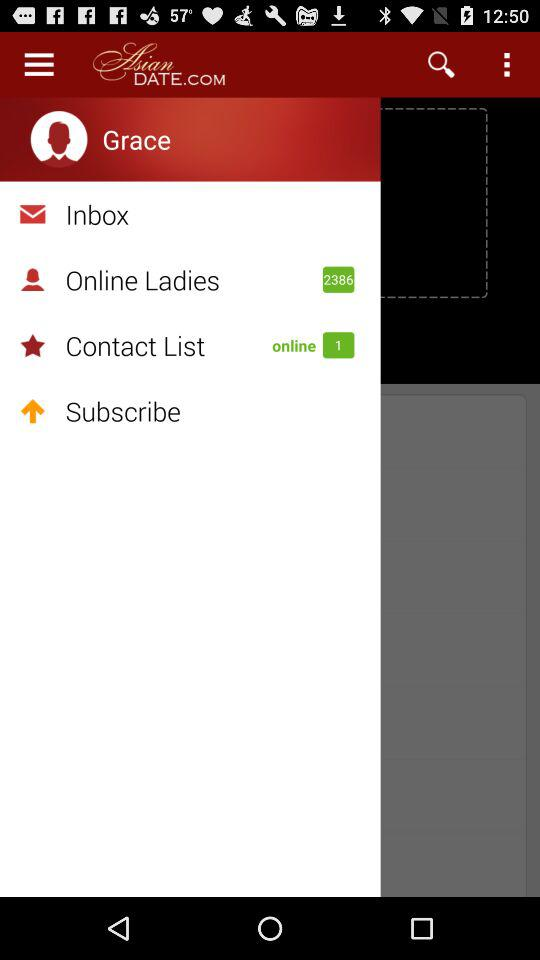How many ladies are there online? There are 2386 ladies online. 